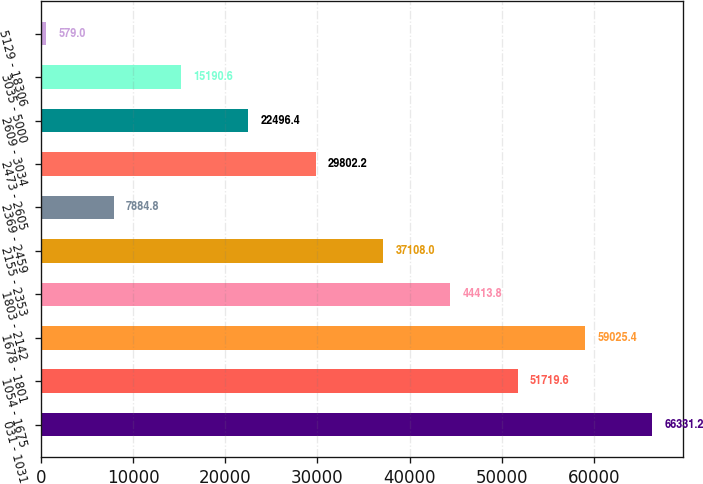<chart> <loc_0><loc_0><loc_500><loc_500><bar_chart><fcel>031 - 1031<fcel>1054 - 1675<fcel>1678 - 1801<fcel>1803 - 2142<fcel>2155 - 2353<fcel>2369 - 2459<fcel>2473 - 2605<fcel>2609 - 3034<fcel>3035 - 5000<fcel>5129 - 18306<nl><fcel>66331.2<fcel>51719.6<fcel>59025.4<fcel>44413.8<fcel>37108<fcel>7884.8<fcel>29802.2<fcel>22496.4<fcel>15190.6<fcel>579<nl></chart> 